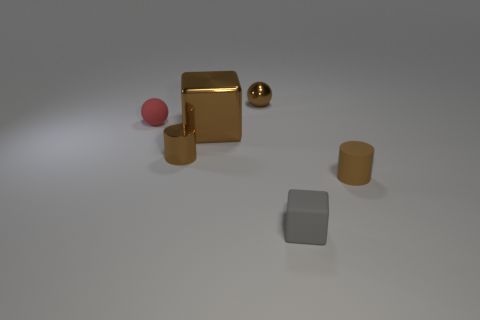There is a tiny matte object that is the same color as the large metallic object; what is its shape?
Your response must be concise. Cylinder. There is a brown object on the right side of the gray rubber object; what is its material?
Your answer should be compact. Rubber. What is the object that is to the right of the tiny red thing and on the left side of the large metallic block made of?
Your answer should be compact. Metal. Does the brown metal thing that is behind the red thing have the same size as the small metal cylinder?
Give a very brief answer. Yes. What shape is the red object?
Keep it short and to the point. Sphere. What number of other small gray objects have the same shape as the small gray object?
Offer a terse response. 0. How many brown things are in front of the small red matte sphere and to the left of the tiny gray rubber object?
Make the answer very short. 2. What color is the small metal sphere?
Offer a very short reply. Brown. Are there any small cylinders made of the same material as the gray block?
Your answer should be compact. Yes. Is there a big cube that is in front of the tiny brown cylinder behind the brown cylinder to the right of the matte block?
Your answer should be very brief. No. 